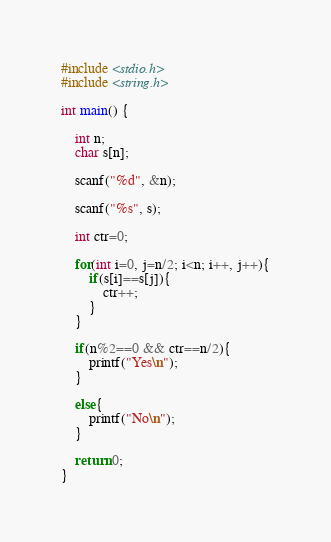<code> <loc_0><loc_0><loc_500><loc_500><_C_>#include <stdio.h>
#include <string.h>

int main() {
	
	int n;
	char s[n];
	
	scanf("%d", &n);
	
	scanf("%s", s);
	
	int ctr=0;
	
	for(int i=0, j=n/2; i<n; i++, j++){
		if(s[i]==s[j]){
			ctr++;
		}
	}
	
	if(n%2==0 && ctr==n/2){
		printf("Yes\n");
	}
		
	else{
		printf("No\n");
	}
	
	return 0;
}</code> 